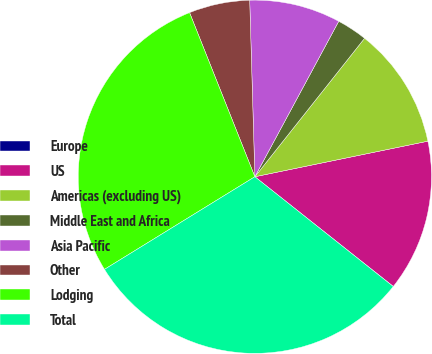<chart> <loc_0><loc_0><loc_500><loc_500><pie_chart><fcel>Europe<fcel>US<fcel>Americas (excluding US)<fcel>Middle East and Africa<fcel>Asia Pacific<fcel>Other<fcel>Lodging<fcel>Total<nl><fcel>0.01%<fcel>13.89%<fcel>11.11%<fcel>2.79%<fcel>8.34%<fcel>5.56%<fcel>27.76%<fcel>30.54%<nl></chart> 